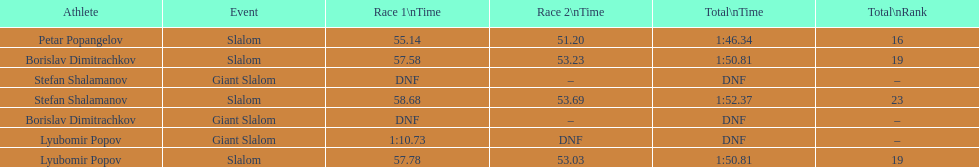How long did it take for lyubomir popov to finish the giant slalom in race 1? 1:10.73. 